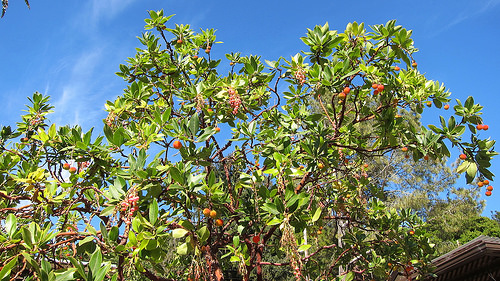<image>
Is the tree on the sky? No. The tree is not positioned on the sky. They may be near each other, but the tree is not supported by or resting on top of the sky. 